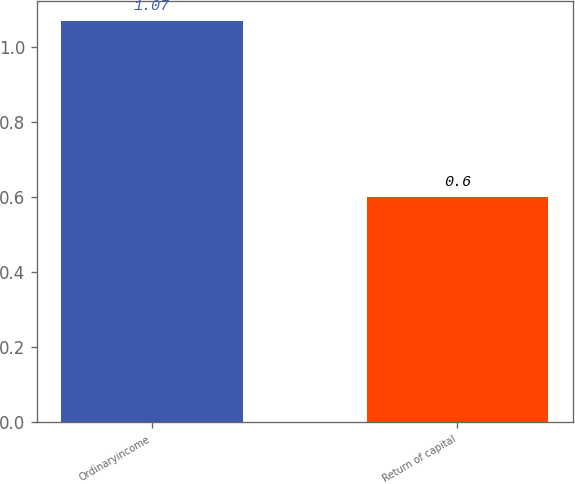<chart> <loc_0><loc_0><loc_500><loc_500><bar_chart><fcel>Ordinaryincome<fcel>Return of capital<nl><fcel>1.07<fcel>0.6<nl></chart> 